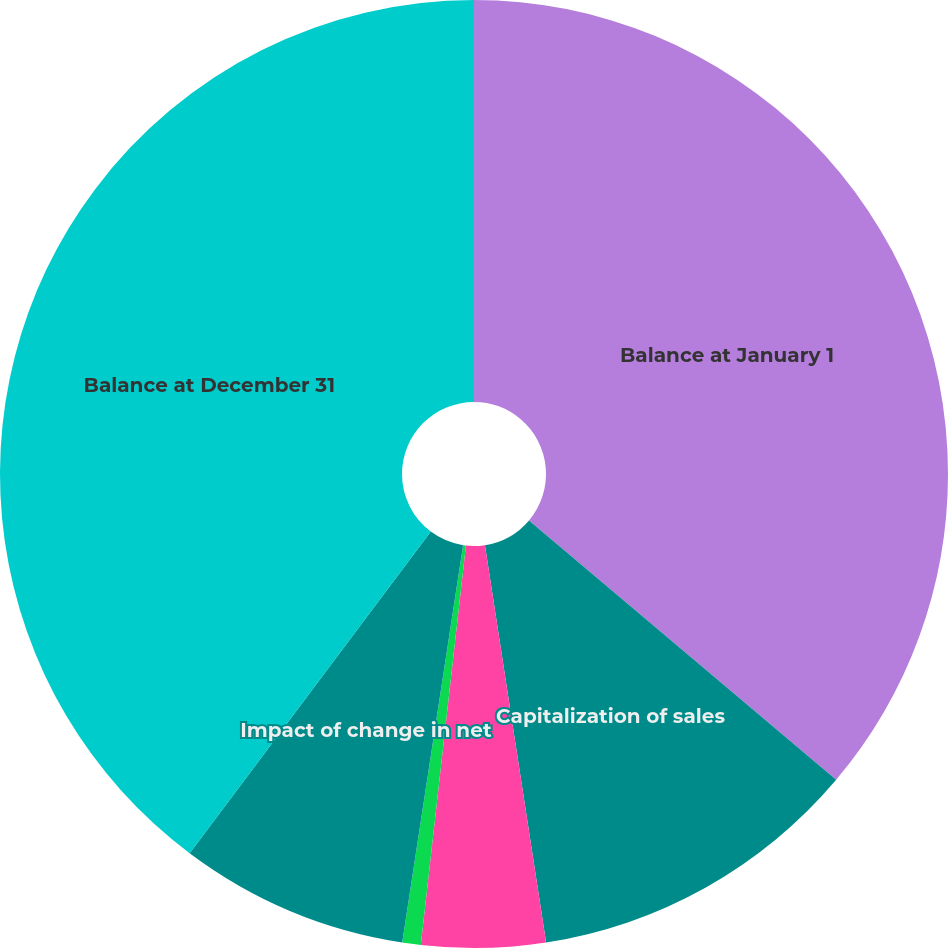<chart> <loc_0><loc_0><loc_500><loc_500><pie_chart><fcel>Balance at January 1<fcel>Capitalization of sales<fcel>Amortization excluding the<fcel>Amortization impact of<fcel>Impact of change in net<fcel>Balance at December 31<nl><fcel>36.16%<fcel>11.41%<fcel>4.22%<fcel>0.63%<fcel>7.82%<fcel>39.76%<nl></chart> 